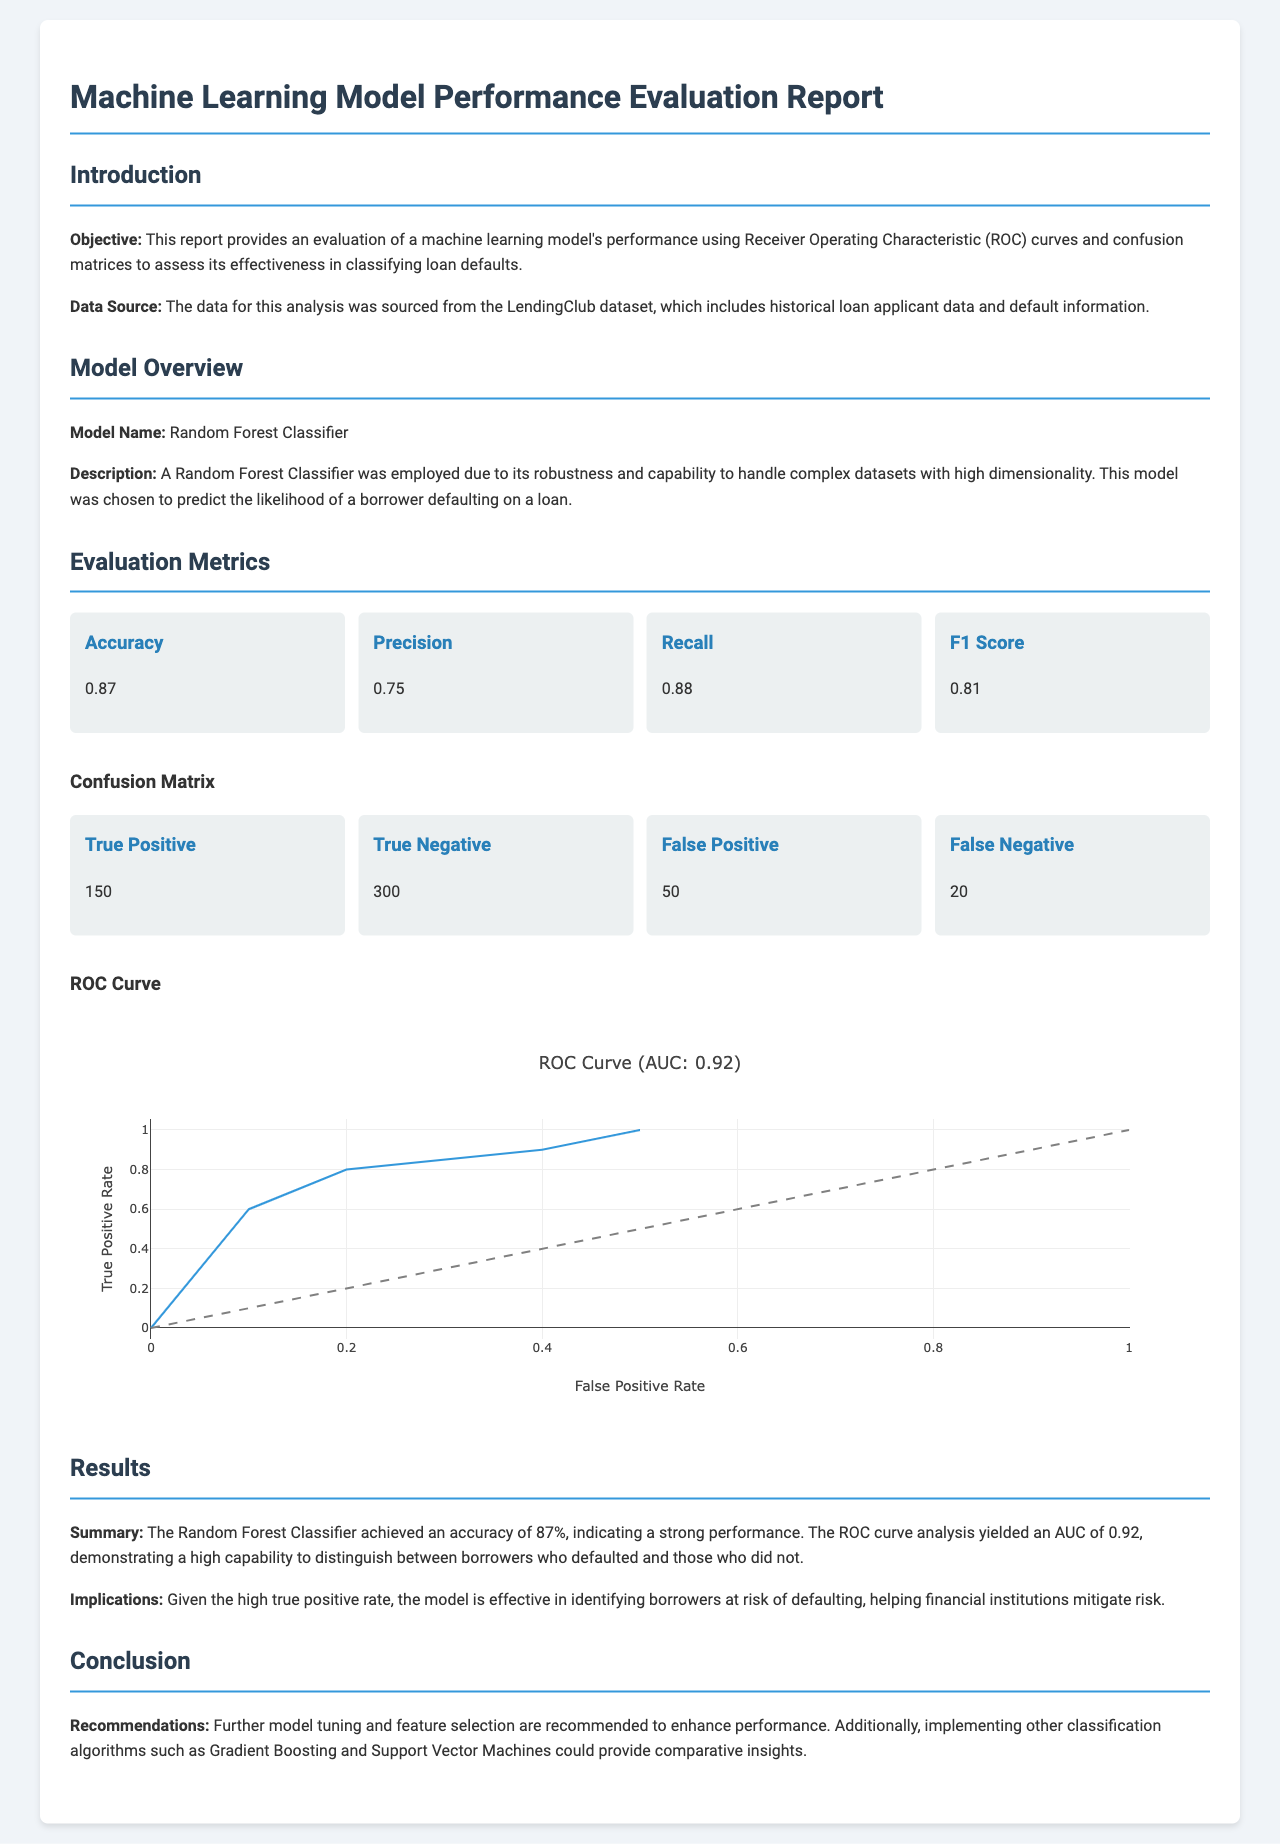What is the model used for evaluation? The model employed for evaluation as stated in the document is a Random Forest Classifier.
Answer: Random Forest Classifier What was the accuracy of the model? The document specifies that the model's accuracy is 0.87.
Answer: 0.87 What is the recall value mentioned in the report? According to the evaluation metrics in the document, the recall value is 0.88.
Answer: 0.88 How many true positives were reported? The confusion matrix section indicates that the number of true positives is 150.
Answer: 150 What is the AUC value for the ROC Curve? The results section mentions an AUC of 0.92 for the ROC analysis.
Answer: 0.92 What does a precision of 0.75 indicate? The precision metric shows the ability of the model to correctly identify positive cases, which is stated as 0.75.
Answer: 0.75 What is the number of false negatives? From the confusion matrix data, the number of false negatives is provided as 20.
Answer: 20 Which data source was used for this analysis? The document specifies that the data source for the analysis is the LendingClub dataset.
Answer: LendingClub dataset What is recommended for further model improvement? The conclusion section suggests further model tuning and feature selection as recommendations for enhancing performance.
Answer: Further model tuning and feature selection 